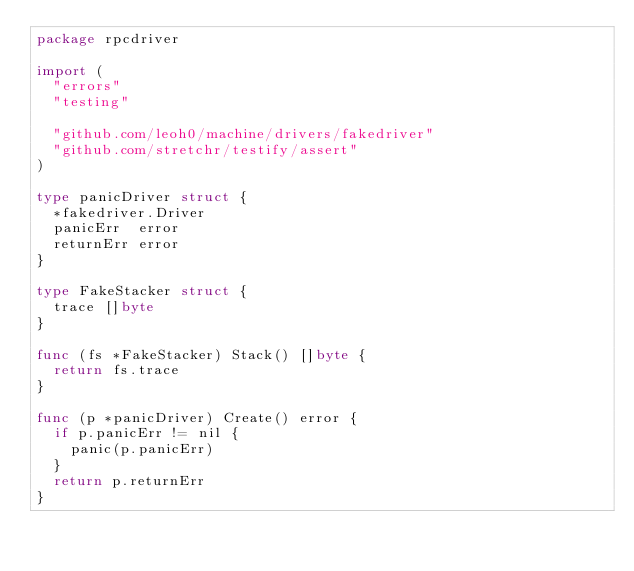Convert code to text. <code><loc_0><loc_0><loc_500><loc_500><_Go_>package rpcdriver

import (
	"errors"
	"testing"

	"github.com/leoh0/machine/drivers/fakedriver"
	"github.com/stretchr/testify/assert"
)

type panicDriver struct {
	*fakedriver.Driver
	panicErr  error
	returnErr error
}

type FakeStacker struct {
	trace []byte
}

func (fs *FakeStacker) Stack() []byte {
	return fs.trace
}

func (p *panicDriver) Create() error {
	if p.panicErr != nil {
		panic(p.panicErr)
	}
	return p.returnErr
}
</code> 